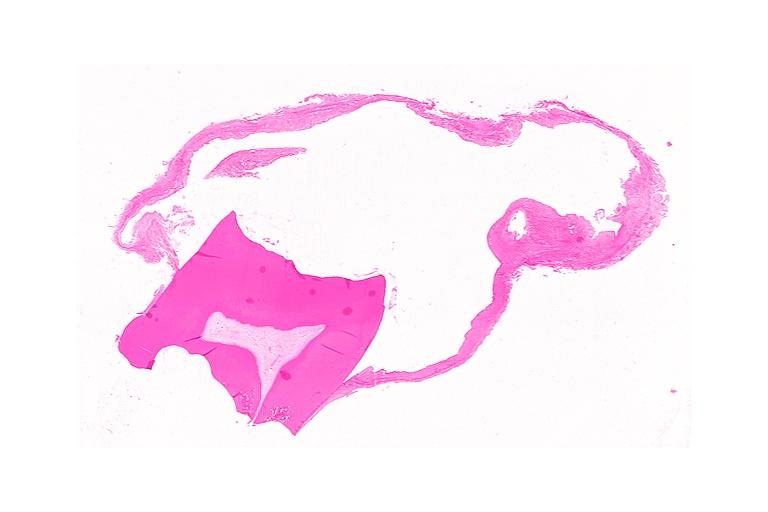what is present?
Answer the question using a single word or phrase. Oral 